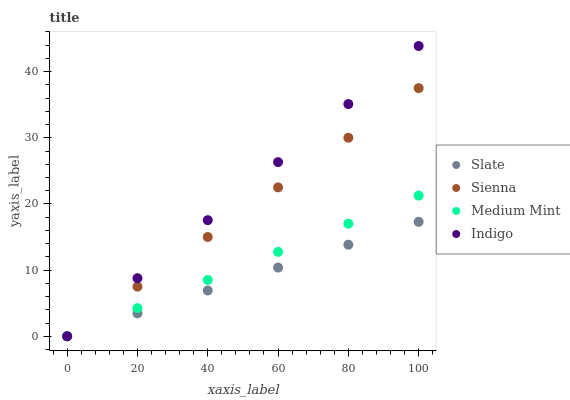Does Slate have the minimum area under the curve?
Answer yes or no. Yes. Does Indigo have the maximum area under the curve?
Answer yes or no. Yes. Does Medium Mint have the minimum area under the curve?
Answer yes or no. No. Does Medium Mint have the maximum area under the curve?
Answer yes or no. No. Is Sienna the smoothest?
Answer yes or no. Yes. Is Indigo the roughest?
Answer yes or no. Yes. Is Medium Mint the smoothest?
Answer yes or no. No. Is Medium Mint the roughest?
Answer yes or no. No. Does Sienna have the lowest value?
Answer yes or no. Yes. Does Indigo have the highest value?
Answer yes or no. Yes. Does Medium Mint have the highest value?
Answer yes or no. No. Does Sienna intersect Medium Mint?
Answer yes or no. Yes. Is Sienna less than Medium Mint?
Answer yes or no. No. Is Sienna greater than Medium Mint?
Answer yes or no. No. 